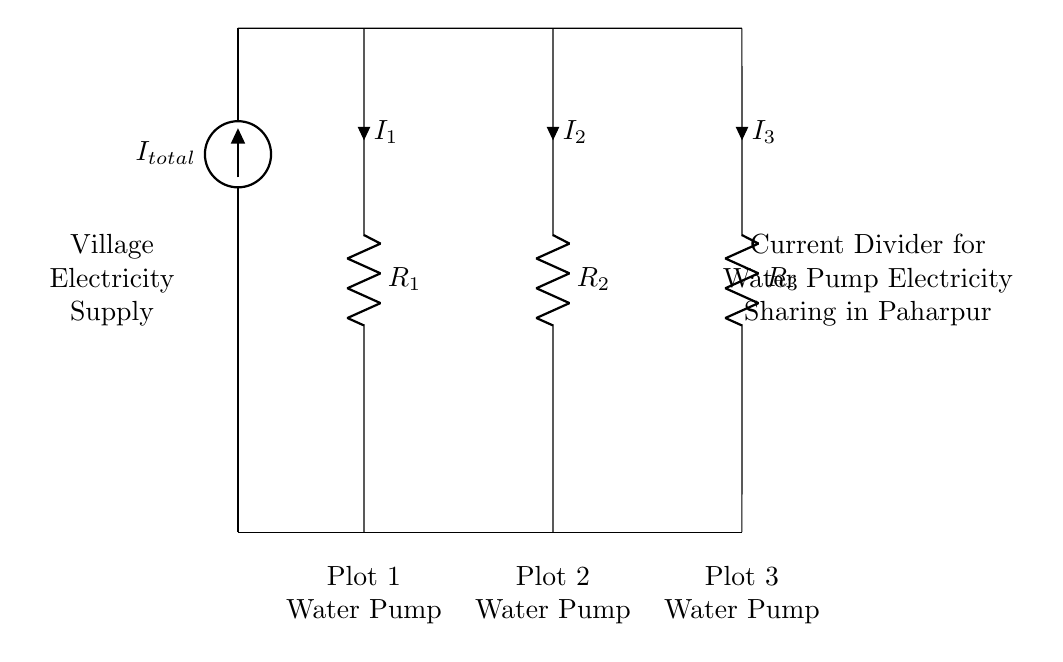What is the total current supplied to the circuit? The total current, represented by I_total at the source, is the sum of the currents flowing through the three resistors. It is not directly specified here but is indicated to provide electricity for the water pumps.
Answer: I_total Which component represents the water pump in Plot 1? The resistor labeled R_1 is associated with Plot 1, indicating that it represents the water pump for that plot.
Answer: R_1 How many water pumps receive electricity in this setup? There are three resistors in the circuit, indicating that there are three separate water pumps, one for each plot.
Answer: Three If all resistors have equal resistance, how is the current shared? In a current divider, if all resistors have equal resistance, the total current divides equally among them. Therefore, each water pump would receive an equal share of the electricity.
Answer: Equally What does the notation "I_1" indicate in the circuit? The notation "I_1" indicates the current flowing through the resistor R_1, which is connected to Plot 1's water pump. It shows the amount of current being used by that pump.
Answer: Current through R_1 Why is the current divider used in this circuit? A current divider is used to distribute the total current among multiple branches (water pumps) based on their resistances, allowing efficient sharing of electricity without overload on any single pump.
Answer: To share current among pumps 